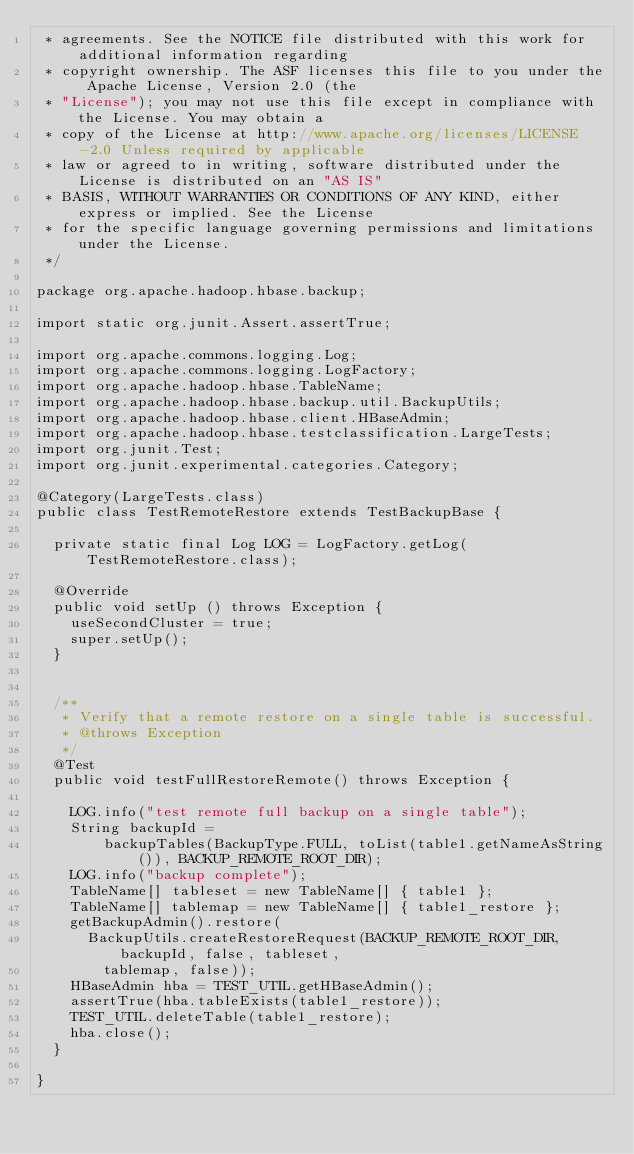Convert code to text. <code><loc_0><loc_0><loc_500><loc_500><_Java_> * agreements. See the NOTICE file distributed with this work for additional information regarding
 * copyright ownership. The ASF licenses this file to you under the Apache License, Version 2.0 (the
 * "License"); you may not use this file except in compliance with the License. You may obtain a
 * copy of the License at http://www.apache.org/licenses/LICENSE-2.0 Unless required by applicable
 * law or agreed to in writing, software distributed under the License is distributed on an "AS IS"
 * BASIS, WITHOUT WARRANTIES OR CONDITIONS OF ANY KIND, either express or implied. See the License
 * for the specific language governing permissions and limitations under the License.
 */

package org.apache.hadoop.hbase.backup;

import static org.junit.Assert.assertTrue;

import org.apache.commons.logging.Log;
import org.apache.commons.logging.LogFactory;
import org.apache.hadoop.hbase.TableName;
import org.apache.hadoop.hbase.backup.util.BackupUtils;
import org.apache.hadoop.hbase.client.HBaseAdmin;
import org.apache.hadoop.hbase.testclassification.LargeTests;
import org.junit.Test;
import org.junit.experimental.categories.Category;

@Category(LargeTests.class)
public class TestRemoteRestore extends TestBackupBase {

  private static final Log LOG = LogFactory.getLog(TestRemoteRestore.class);

  @Override
  public void setUp () throws Exception {
    useSecondCluster = true;
    super.setUp();
  }


  /**
   * Verify that a remote restore on a single table is successful.
   * @throws Exception
   */
  @Test
  public void testFullRestoreRemote() throws Exception {

    LOG.info("test remote full backup on a single table");
    String backupId =
        backupTables(BackupType.FULL, toList(table1.getNameAsString()), BACKUP_REMOTE_ROOT_DIR);
    LOG.info("backup complete");
    TableName[] tableset = new TableName[] { table1 };
    TableName[] tablemap = new TableName[] { table1_restore };
    getBackupAdmin().restore(
      BackupUtils.createRestoreRequest(BACKUP_REMOTE_ROOT_DIR, backupId, false, tableset,
        tablemap, false));
    HBaseAdmin hba = TEST_UTIL.getHBaseAdmin();
    assertTrue(hba.tableExists(table1_restore));
    TEST_UTIL.deleteTable(table1_restore);
    hba.close();
  }

}
</code> 